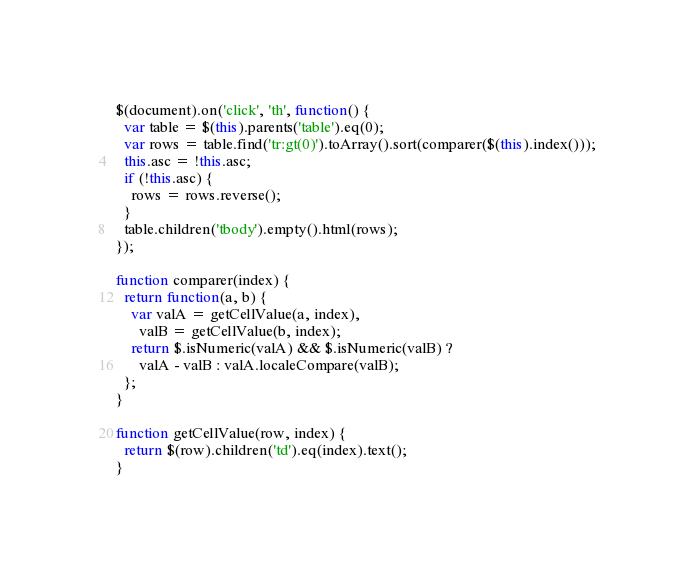Convert code to text. <code><loc_0><loc_0><loc_500><loc_500><_JavaScript_>$(document).on('click', 'th', function() {
  var table = $(this).parents('table').eq(0);
  var rows = table.find('tr:gt(0)').toArray().sort(comparer($(this).index()));
  this.asc = !this.asc;
  if (!this.asc) {
    rows = rows.reverse();
  }
  table.children('tbody').empty().html(rows);
});

function comparer(index) {
  return function(a, b) {
    var valA = getCellValue(a, index),
      valB = getCellValue(b, index);
    return $.isNumeric(valA) && $.isNumeric(valB) ?
      valA - valB : valA.localeCompare(valB);
  };
}

function getCellValue(row, index) {
  return $(row).children('td').eq(index).text();
}
</code> 